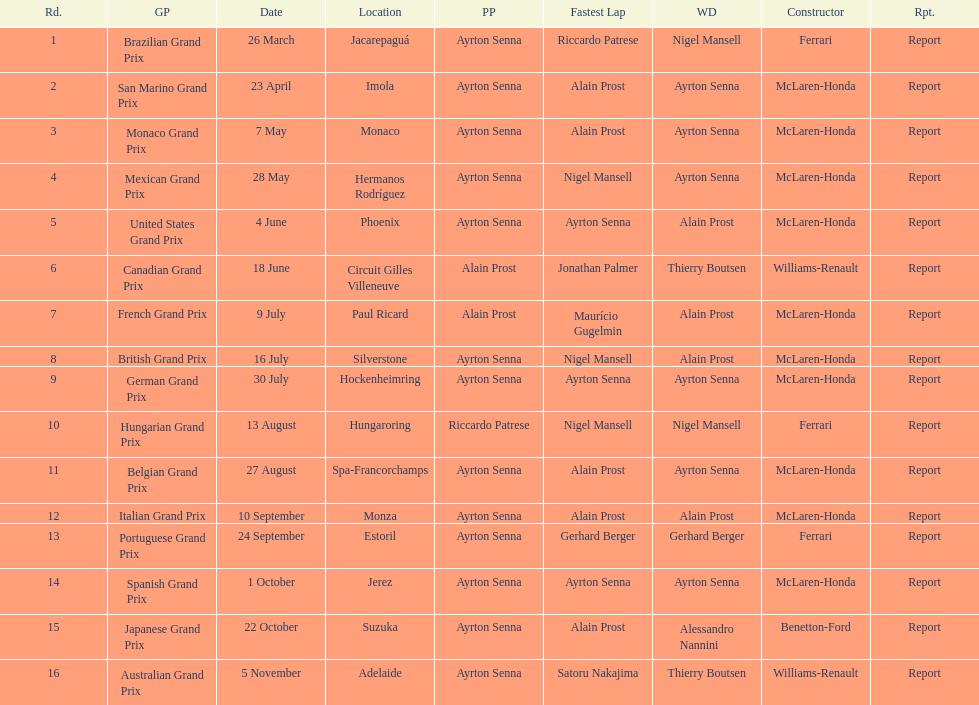What number of races happened prior to alain prost achieving a pole position? 5. 